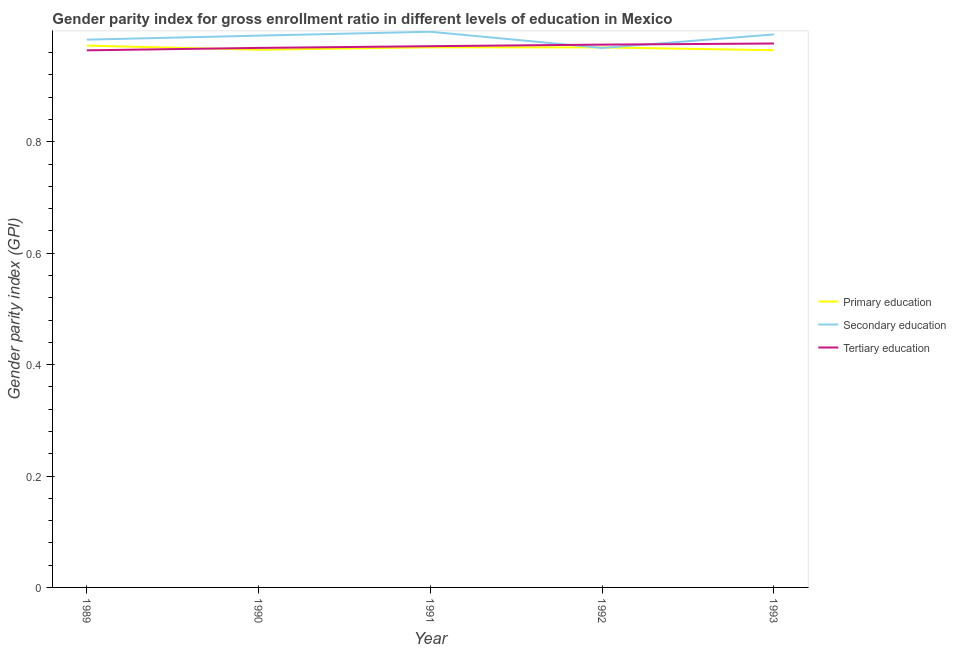Does the line corresponding to gender parity index in primary education intersect with the line corresponding to gender parity index in secondary education?
Your answer should be very brief. Yes. Is the number of lines equal to the number of legend labels?
Your answer should be compact. Yes. What is the gender parity index in primary education in 1991?
Provide a short and direct response. 0.97. Across all years, what is the maximum gender parity index in primary education?
Offer a terse response. 0.97. Across all years, what is the minimum gender parity index in secondary education?
Your answer should be compact. 0.97. In which year was the gender parity index in tertiary education minimum?
Provide a short and direct response. 1989. What is the total gender parity index in primary education in the graph?
Ensure brevity in your answer.  4.84. What is the difference between the gender parity index in secondary education in 1990 and that in 1993?
Keep it short and to the point. -0. What is the difference between the gender parity index in tertiary education in 1990 and the gender parity index in primary education in 1992?
Provide a succinct answer. -0. What is the average gender parity index in primary education per year?
Your answer should be compact. 0.97. In the year 1990, what is the difference between the gender parity index in primary education and gender parity index in tertiary education?
Ensure brevity in your answer.  -0. What is the ratio of the gender parity index in secondary education in 1991 to that in 1992?
Ensure brevity in your answer.  1.03. Is the gender parity index in tertiary education in 1991 less than that in 1993?
Offer a very short reply. Yes. Is the difference between the gender parity index in tertiary education in 1990 and 1991 greater than the difference between the gender parity index in secondary education in 1990 and 1991?
Ensure brevity in your answer.  Yes. What is the difference between the highest and the second highest gender parity index in tertiary education?
Provide a short and direct response. 0. What is the difference between the highest and the lowest gender parity index in secondary education?
Provide a short and direct response. 0.03. Does the gender parity index in primary education monotonically increase over the years?
Offer a terse response. No. What is the difference between two consecutive major ticks on the Y-axis?
Ensure brevity in your answer.  0.2. Does the graph contain any zero values?
Ensure brevity in your answer.  No. Does the graph contain grids?
Keep it short and to the point. No. How many legend labels are there?
Make the answer very short. 3. How are the legend labels stacked?
Your response must be concise. Vertical. What is the title of the graph?
Your answer should be very brief. Gender parity index for gross enrollment ratio in different levels of education in Mexico. Does "Ages 15-20" appear as one of the legend labels in the graph?
Ensure brevity in your answer.  No. What is the label or title of the X-axis?
Offer a very short reply. Year. What is the label or title of the Y-axis?
Your answer should be compact. Gender parity index (GPI). What is the Gender parity index (GPI) in Primary education in 1989?
Provide a short and direct response. 0.97. What is the Gender parity index (GPI) of Secondary education in 1989?
Your response must be concise. 0.98. What is the Gender parity index (GPI) in Tertiary education in 1989?
Provide a succinct answer. 0.96. What is the Gender parity index (GPI) in Primary education in 1990?
Make the answer very short. 0.97. What is the Gender parity index (GPI) in Secondary education in 1990?
Provide a short and direct response. 0.99. What is the Gender parity index (GPI) of Tertiary education in 1990?
Your answer should be very brief. 0.97. What is the Gender parity index (GPI) in Primary education in 1991?
Your answer should be compact. 0.97. What is the Gender parity index (GPI) of Secondary education in 1991?
Keep it short and to the point. 1. What is the Gender parity index (GPI) in Tertiary education in 1991?
Your response must be concise. 0.97. What is the Gender parity index (GPI) in Primary education in 1992?
Offer a very short reply. 0.97. What is the Gender parity index (GPI) in Secondary education in 1992?
Give a very brief answer. 0.97. What is the Gender parity index (GPI) in Tertiary education in 1992?
Your answer should be compact. 0.97. What is the Gender parity index (GPI) in Primary education in 1993?
Your answer should be very brief. 0.96. What is the Gender parity index (GPI) in Secondary education in 1993?
Ensure brevity in your answer.  0.99. What is the Gender parity index (GPI) in Tertiary education in 1993?
Provide a succinct answer. 0.98. Across all years, what is the maximum Gender parity index (GPI) of Primary education?
Offer a terse response. 0.97. Across all years, what is the maximum Gender parity index (GPI) of Secondary education?
Your answer should be compact. 1. Across all years, what is the maximum Gender parity index (GPI) in Tertiary education?
Keep it short and to the point. 0.98. Across all years, what is the minimum Gender parity index (GPI) in Primary education?
Your answer should be compact. 0.96. Across all years, what is the minimum Gender parity index (GPI) in Secondary education?
Provide a succinct answer. 0.97. Across all years, what is the minimum Gender parity index (GPI) in Tertiary education?
Keep it short and to the point. 0.96. What is the total Gender parity index (GPI) of Primary education in the graph?
Make the answer very short. 4.84. What is the total Gender parity index (GPI) of Secondary education in the graph?
Provide a succinct answer. 4.93. What is the total Gender parity index (GPI) in Tertiary education in the graph?
Provide a short and direct response. 4.86. What is the difference between the Gender parity index (GPI) in Primary education in 1989 and that in 1990?
Your answer should be compact. 0.01. What is the difference between the Gender parity index (GPI) in Secondary education in 1989 and that in 1990?
Offer a very short reply. -0.01. What is the difference between the Gender parity index (GPI) in Tertiary education in 1989 and that in 1990?
Ensure brevity in your answer.  -0. What is the difference between the Gender parity index (GPI) of Primary education in 1989 and that in 1991?
Offer a very short reply. 0. What is the difference between the Gender parity index (GPI) in Secondary education in 1989 and that in 1991?
Your answer should be compact. -0.01. What is the difference between the Gender parity index (GPI) of Tertiary education in 1989 and that in 1991?
Provide a short and direct response. -0.01. What is the difference between the Gender parity index (GPI) of Primary education in 1989 and that in 1992?
Keep it short and to the point. 0. What is the difference between the Gender parity index (GPI) of Secondary education in 1989 and that in 1992?
Provide a succinct answer. 0.01. What is the difference between the Gender parity index (GPI) of Tertiary education in 1989 and that in 1992?
Your answer should be very brief. -0.01. What is the difference between the Gender parity index (GPI) of Primary education in 1989 and that in 1993?
Provide a succinct answer. 0.01. What is the difference between the Gender parity index (GPI) in Secondary education in 1989 and that in 1993?
Keep it short and to the point. -0.01. What is the difference between the Gender parity index (GPI) in Tertiary education in 1989 and that in 1993?
Ensure brevity in your answer.  -0.01. What is the difference between the Gender parity index (GPI) in Primary education in 1990 and that in 1991?
Your answer should be compact. -0. What is the difference between the Gender parity index (GPI) of Secondary education in 1990 and that in 1991?
Give a very brief answer. -0.01. What is the difference between the Gender parity index (GPI) of Tertiary education in 1990 and that in 1991?
Give a very brief answer. -0. What is the difference between the Gender parity index (GPI) in Primary education in 1990 and that in 1992?
Your answer should be compact. -0. What is the difference between the Gender parity index (GPI) in Secondary education in 1990 and that in 1992?
Keep it short and to the point. 0.02. What is the difference between the Gender parity index (GPI) of Tertiary education in 1990 and that in 1992?
Your answer should be compact. -0.01. What is the difference between the Gender parity index (GPI) in Primary education in 1990 and that in 1993?
Provide a succinct answer. 0. What is the difference between the Gender parity index (GPI) in Secondary education in 1990 and that in 1993?
Offer a terse response. -0. What is the difference between the Gender parity index (GPI) of Tertiary education in 1990 and that in 1993?
Ensure brevity in your answer.  -0.01. What is the difference between the Gender parity index (GPI) in Primary education in 1991 and that in 1992?
Give a very brief answer. 0. What is the difference between the Gender parity index (GPI) of Secondary education in 1991 and that in 1992?
Ensure brevity in your answer.  0.03. What is the difference between the Gender parity index (GPI) of Tertiary education in 1991 and that in 1992?
Make the answer very short. -0. What is the difference between the Gender parity index (GPI) of Primary education in 1991 and that in 1993?
Offer a terse response. 0.01. What is the difference between the Gender parity index (GPI) in Secondary education in 1991 and that in 1993?
Provide a short and direct response. 0. What is the difference between the Gender parity index (GPI) in Tertiary education in 1991 and that in 1993?
Keep it short and to the point. -0. What is the difference between the Gender parity index (GPI) of Primary education in 1992 and that in 1993?
Your answer should be compact. 0.01. What is the difference between the Gender parity index (GPI) of Secondary education in 1992 and that in 1993?
Your response must be concise. -0.02. What is the difference between the Gender parity index (GPI) in Tertiary education in 1992 and that in 1993?
Your answer should be very brief. -0. What is the difference between the Gender parity index (GPI) of Primary education in 1989 and the Gender parity index (GPI) of Secondary education in 1990?
Ensure brevity in your answer.  -0.02. What is the difference between the Gender parity index (GPI) of Primary education in 1989 and the Gender parity index (GPI) of Tertiary education in 1990?
Offer a very short reply. 0. What is the difference between the Gender parity index (GPI) of Secondary education in 1989 and the Gender parity index (GPI) of Tertiary education in 1990?
Give a very brief answer. 0.01. What is the difference between the Gender parity index (GPI) in Primary education in 1989 and the Gender parity index (GPI) in Secondary education in 1991?
Give a very brief answer. -0.02. What is the difference between the Gender parity index (GPI) of Primary education in 1989 and the Gender parity index (GPI) of Tertiary education in 1991?
Provide a short and direct response. 0. What is the difference between the Gender parity index (GPI) in Secondary education in 1989 and the Gender parity index (GPI) in Tertiary education in 1991?
Make the answer very short. 0.01. What is the difference between the Gender parity index (GPI) of Primary education in 1989 and the Gender parity index (GPI) of Secondary education in 1992?
Keep it short and to the point. 0. What is the difference between the Gender parity index (GPI) of Primary education in 1989 and the Gender parity index (GPI) of Tertiary education in 1992?
Your response must be concise. -0. What is the difference between the Gender parity index (GPI) in Secondary education in 1989 and the Gender parity index (GPI) in Tertiary education in 1992?
Your answer should be very brief. 0.01. What is the difference between the Gender parity index (GPI) in Primary education in 1989 and the Gender parity index (GPI) in Secondary education in 1993?
Provide a succinct answer. -0.02. What is the difference between the Gender parity index (GPI) in Primary education in 1989 and the Gender parity index (GPI) in Tertiary education in 1993?
Provide a short and direct response. -0. What is the difference between the Gender parity index (GPI) in Secondary education in 1989 and the Gender parity index (GPI) in Tertiary education in 1993?
Make the answer very short. 0.01. What is the difference between the Gender parity index (GPI) of Primary education in 1990 and the Gender parity index (GPI) of Secondary education in 1991?
Provide a short and direct response. -0.03. What is the difference between the Gender parity index (GPI) of Primary education in 1990 and the Gender parity index (GPI) of Tertiary education in 1991?
Ensure brevity in your answer.  -0.01. What is the difference between the Gender parity index (GPI) in Secondary education in 1990 and the Gender parity index (GPI) in Tertiary education in 1991?
Offer a very short reply. 0.02. What is the difference between the Gender parity index (GPI) of Primary education in 1990 and the Gender parity index (GPI) of Secondary education in 1992?
Make the answer very short. -0. What is the difference between the Gender parity index (GPI) in Primary education in 1990 and the Gender parity index (GPI) in Tertiary education in 1992?
Give a very brief answer. -0.01. What is the difference between the Gender parity index (GPI) in Secondary education in 1990 and the Gender parity index (GPI) in Tertiary education in 1992?
Provide a succinct answer. 0.02. What is the difference between the Gender parity index (GPI) of Primary education in 1990 and the Gender parity index (GPI) of Secondary education in 1993?
Make the answer very short. -0.03. What is the difference between the Gender parity index (GPI) of Primary education in 1990 and the Gender parity index (GPI) of Tertiary education in 1993?
Your answer should be compact. -0.01. What is the difference between the Gender parity index (GPI) in Secondary education in 1990 and the Gender parity index (GPI) in Tertiary education in 1993?
Your answer should be very brief. 0.01. What is the difference between the Gender parity index (GPI) in Primary education in 1991 and the Gender parity index (GPI) in Secondary education in 1992?
Offer a terse response. 0. What is the difference between the Gender parity index (GPI) of Primary education in 1991 and the Gender parity index (GPI) of Tertiary education in 1992?
Make the answer very short. -0. What is the difference between the Gender parity index (GPI) of Secondary education in 1991 and the Gender parity index (GPI) of Tertiary education in 1992?
Ensure brevity in your answer.  0.02. What is the difference between the Gender parity index (GPI) in Primary education in 1991 and the Gender parity index (GPI) in Secondary education in 1993?
Offer a very short reply. -0.02. What is the difference between the Gender parity index (GPI) of Primary education in 1991 and the Gender parity index (GPI) of Tertiary education in 1993?
Provide a short and direct response. -0.01. What is the difference between the Gender parity index (GPI) of Secondary education in 1991 and the Gender parity index (GPI) of Tertiary education in 1993?
Make the answer very short. 0.02. What is the difference between the Gender parity index (GPI) of Primary education in 1992 and the Gender parity index (GPI) of Secondary education in 1993?
Make the answer very short. -0.02. What is the difference between the Gender parity index (GPI) of Primary education in 1992 and the Gender parity index (GPI) of Tertiary education in 1993?
Your response must be concise. -0.01. What is the difference between the Gender parity index (GPI) in Secondary education in 1992 and the Gender parity index (GPI) in Tertiary education in 1993?
Your answer should be very brief. -0.01. What is the average Gender parity index (GPI) in Primary education per year?
Give a very brief answer. 0.97. What is the average Gender parity index (GPI) of Secondary education per year?
Your answer should be compact. 0.99. In the year 1989, what is the difference between the Gender parity index (GPI) in Primary education and Gender parity index (GPI) in Secondary education?
Give a very brief answer. -0.01. In the year 1989, what is the difference between the Gender parity index (GPI) of Primary education and Gender parity index (GPI) of Tertiary education?
Offer a very short reply. 0.01. In the year 1989, what is the difference between the Gender parity index (GPI) of Secondary education and Gender parity index (GPI) of Tertiary education?
Provide a succinct answer. 0.02. In the year 1990, what is the difference between the Gender parity index (GPI) of Primary education and Gender parity index (GPI) of Secondary education?
Your answer should be compact. -0.03. In the year 1990, what is the difference between the Gender parity index (GPI) in Primary education and Gender parity index (GPI) in Tertiary education?
Offer a terse response. -0. In the year 1990, what is the difference between the Gender parity index (GPI) of Secondary education and Gender parity index (GPI) of Tertiary education?
Your answer should be compact. 0.02. In the year 1991, what is the difference between the Gender parity index (GPI) of Primary education and Gender parity index (GPI) of Secondary education?
Your answer should be compact. -0.03. In the year 1991, what is the difference between the Gender parity index (GPI) of Primary education and Gender parity index (GPI) of Tertiary education?
Your answer should be very brief. -0. In the year 1991, what is the difference between the Gender parity index (GPI) of Secondary education and Gender parity index (GPI) of Tertiary education?
Keep it short and to the point. 0.03. In the year 1992, what is the difference between the Gender parity index (GPI) in Primary education and Gender parity index (GPI) in Tertiary education?
Give a very brief answer. -0.01. In the year 1992, what is the difference between the Gender parity index (GPI) of Secondary education and Gender parity index (GPI) of Tertiary education?
Your answer should be compact. -0.01. In the year 1993, what is the difference between the Gender parity index (GPI) in Primary education and Gender parity index (GPI) in Secondary education?
Give a very brief answer. -0.03. In the year 1993, what is the difference between the Gender parity index (GPI) of Primary education and Gender parity index (GPI) of Tertiary education?
Your response must be concise. -0.01. In the year 1993, what is the difference between the Gender parity index (GPI) of Secondary education and Gender parity index (GPI) of Tertiary education?
Make the answer very short. 0.02. What is the ratio of the Gender parity index (GPI) in Primary education in 1989 to that in 1990?
Keep it short and to the point. 1.01. What is the ratio of the Gender parity index (GPI) of Secondary education in 1989 to that in 1990?
Your answer should be very brief. 0.99. What is the ratio of the Gender parity index (GPI) of Primary education in 1989 to that in 1991?
Offer a terse response. 1. What is the ratio of the Gender parity index (GPI) of Secondary education in 1989 to that in 1991?
Provide a succinct answer. 0.99. What is the ratio of the Gender parity index (GPI) in Secondary education in 1989 to that in 1992?
Your answer should be very brief. 1.02. What is the ratio of the Gender parity index (GPI) in Primary education in 1989 to that in 1993?
Offer a very short reply. 1.01. What is the ratio of the Gender parity index (GPI) of Secondary education in 1989 to that in 1993?
Give a very brief answer. 0.99. What is the ratio of the Gender parity index (GPI) of Tertiary education in 1989 to that in 1993?
Give a very brief answer. 0.99. What is the ratio of the Gender parity index (GPI) in Primary education in 1990 to that in 1991?
Ensure brevity in your answer.  1. What is the ratio of the Gender parity index (GPI) of Tertiary education in 1990 to that in 1991?
Provide a short and direct response. 1. What is the ratio of the Gender parity index (GPI) of Secondary education in 1990 to that in 1992?
Your answer should be very brief. 1.02. What is the ratio of the Gender parity index (GPI) in Primary education in 1990 to that in 1993?
Give a very brief answer. 1. What is the ratio of the Gender parity index (GPI) in Secondary education in 1990 to that in 1993?
Offer a terse response. 1. What is the ratio of the Gender parity index (GPI) of Tertiary education in 1990 to that in 1993?
Ensure brevity in your answer.  0.99. What is the ratio of the Gender parity index (GPI) in Secondary education in 1991 to that in 1992?
Provide a short and direct response. 1.03. What is the ratio of the Gender parity index (GPI) of Tertiary education in 1991 to that in 1992?
Keep it short and to the point. 1. What is the ratio of the Gender parity index (GPI) of Primary education in 1991 to that in 1993?
Ensure brevity in your answer.  1.01. What is the ratio of the Gender parity index (GPI) in Tertiary education in 1991 to that in 1993?
Provide a short and direct response. 1. What is the ratio of the Gender parity index (GPI) in Primary education in 1992 to that in 1993?
Your response must be concise. 1.01. What is the ratio of the Gender parity index (GPI) in Secondary education in 1992 to that in 1993?
Make the answer very short. 0.98. What is the difference between the highest and the second highest Gender parity index (GPI) of Primary education?
Provide a short and direct response. 0. What is the difference between the highest and the second highest Gender parity index (GPI) in Secondary education?
Give a very brief answer. 0. What is the difference between the highest and the second highest Gender parity index (GPI) in Tertiary education?
Your response must be concise. 0. What is the difference between the highest and the lowest Gender parity index (GPI) of Primary education?
Keep it short and to the point. 0.01. What is the difference between the highest and the lowest Gender parity index (GPI) of Secondary education?
Make the answer very short. 0.03. What is the difference between the highest and the lowest Gender parity index (GPI) in Tertiary education?
Make the answer very short. 0.01. 